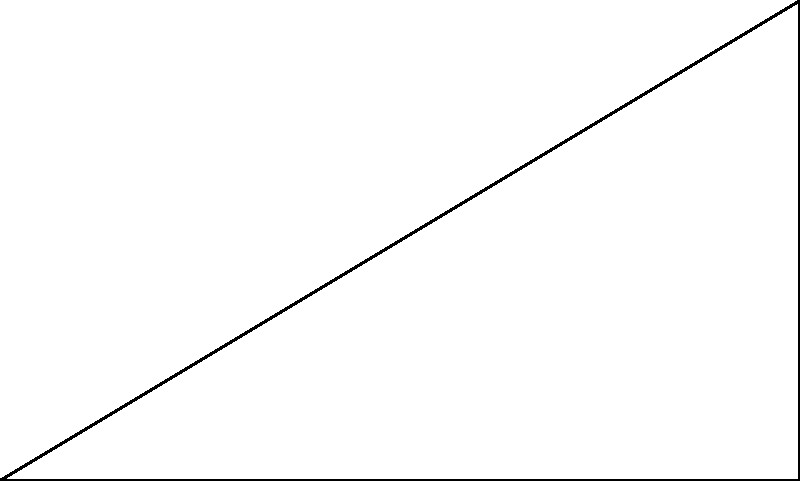Your child is working on a physics homework problem involving a book sliding down an inclined plane. The force diagram shows four forces acting on the book: gravity ($mg$), normal force ($N$), friction ($f$), and acceleration ($a$). If the coefficient of friction between the book and the plane is 0.3, and the angle of inclination is 30°, what is the magnitude of the book's acceleration in terms of $g$ (acceleration due to gravity)? Let's approach this step-by-step:

1) First, we need to resolve the forces parallel and perpendicular to the inclined plane.

2) The force of gravity ($mg$) can be resolved into two components:
   - Parallel to the plane: $mg \sin \theta$
   - Perpendicular to the plane: $mg \cos \theta$

3) The normal force $N$ is equal and opposite to the perpendicular component of gravity:
   $N = mg \cos \theta$

4) The friction force $f$ is given by:
   $f = \mu N = \mu mg \cos \theta$
   where $\mu$ is the coefficient of friction (0.3 in this case)

5) Now, we can write Newton's Second Law for the forces parallel to the plane:
   $mg \sin \theta - f = ma$

6) Substituting the expression for $f$:
   $mg \sin \theta - \mu mg \cos \theta = ma$

7) Dividing both sides by $m$:
   $g \sin \theta - \mu g \cos \theta = a$

8) Now, let's substitute the given values:
   $\theta = 30°$, $\mu = 0.3$

9) $a = g \sin 30° - 0.3g \cos 30°$
      $= 0.5g - 0.3(0.866g)$
      $= 0.5g - 0.2598g$
      $= 0.2402g$

Therefore, the magnitude of the book's acceleration is approximately $0.24g$.
Answer: $0.24g$ 